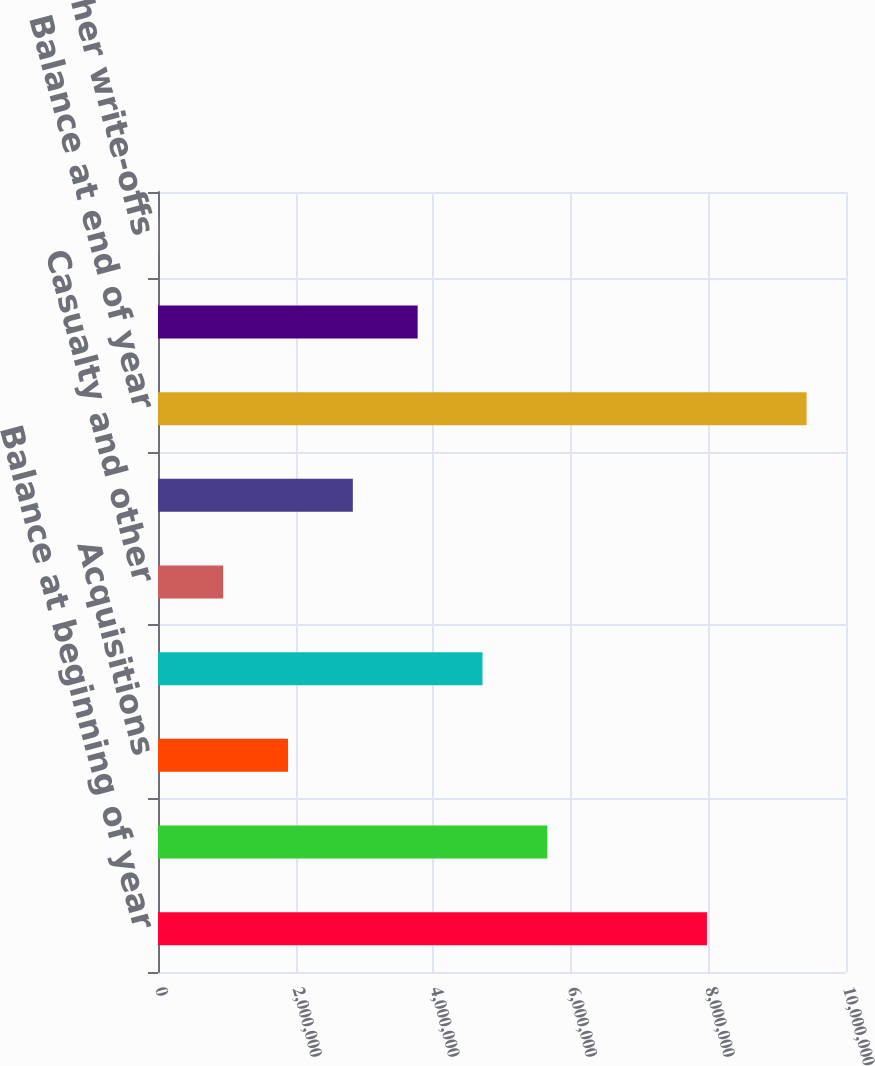Convert chart. <chart><loc_0><loc_0><loc_500><loc_500><bar_chart><fcel>Balance at beginning of year<fcel>Newly consolidated assets and<fcel>Acquisitions<fcel>Capital expenditures<fcel>Casualty and other<fcel>Assets held for sale<fcel>Balance at end of year<fcel>Depreciation<fcel>Casualty and other write-offs<nl><fcel>7.97899e+06<fcel>5.6584e+06<fcel>1.88987e+06<fcel>4.71626e+06<fcel>947736<fcel>2.832e+06<fcel>9.42692e+06<fcel>3.77413e+06<fcel>5604<nl></chart> 